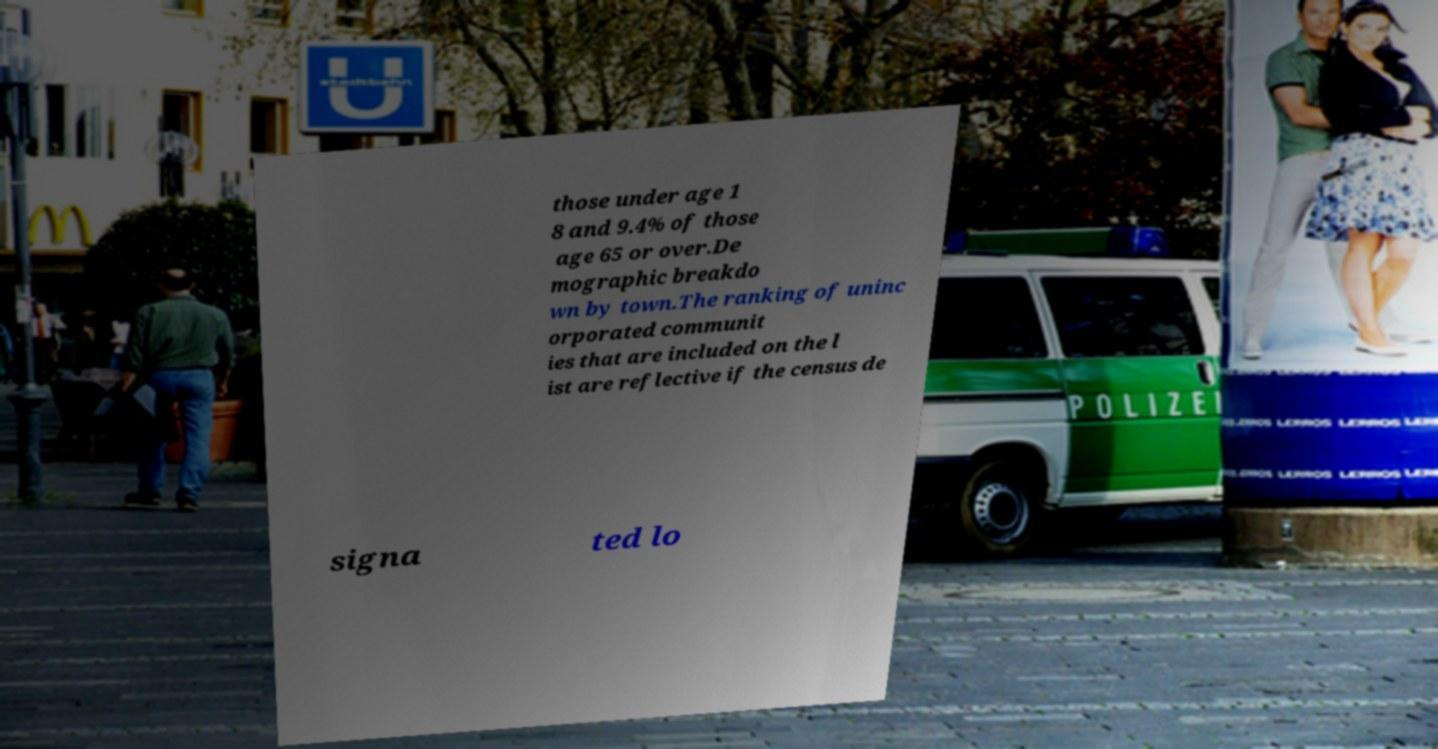Can you read and provide the text displayed in the image?This photo seems to have some interesting text. Can you extract and type it out for me? those under age 1 8 and 9.4% of those age 65 or over.De mographic breakdo wn by town.The ranking of uninc orporated communit ies that are included on the l ist are reflective if the census de signa ted lo 